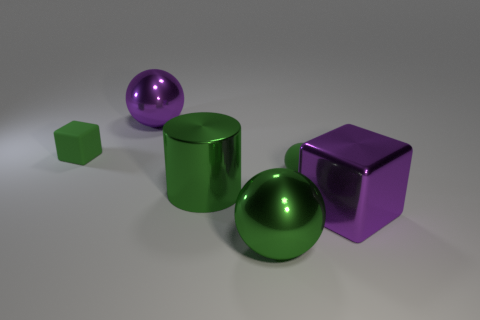What is the color of the metallic cylinder? The metallic cylinder in the image has a reflective, vibrant green surface, surrounded by other geometric shapes that also exhibit a glossy finish in varying hues. 